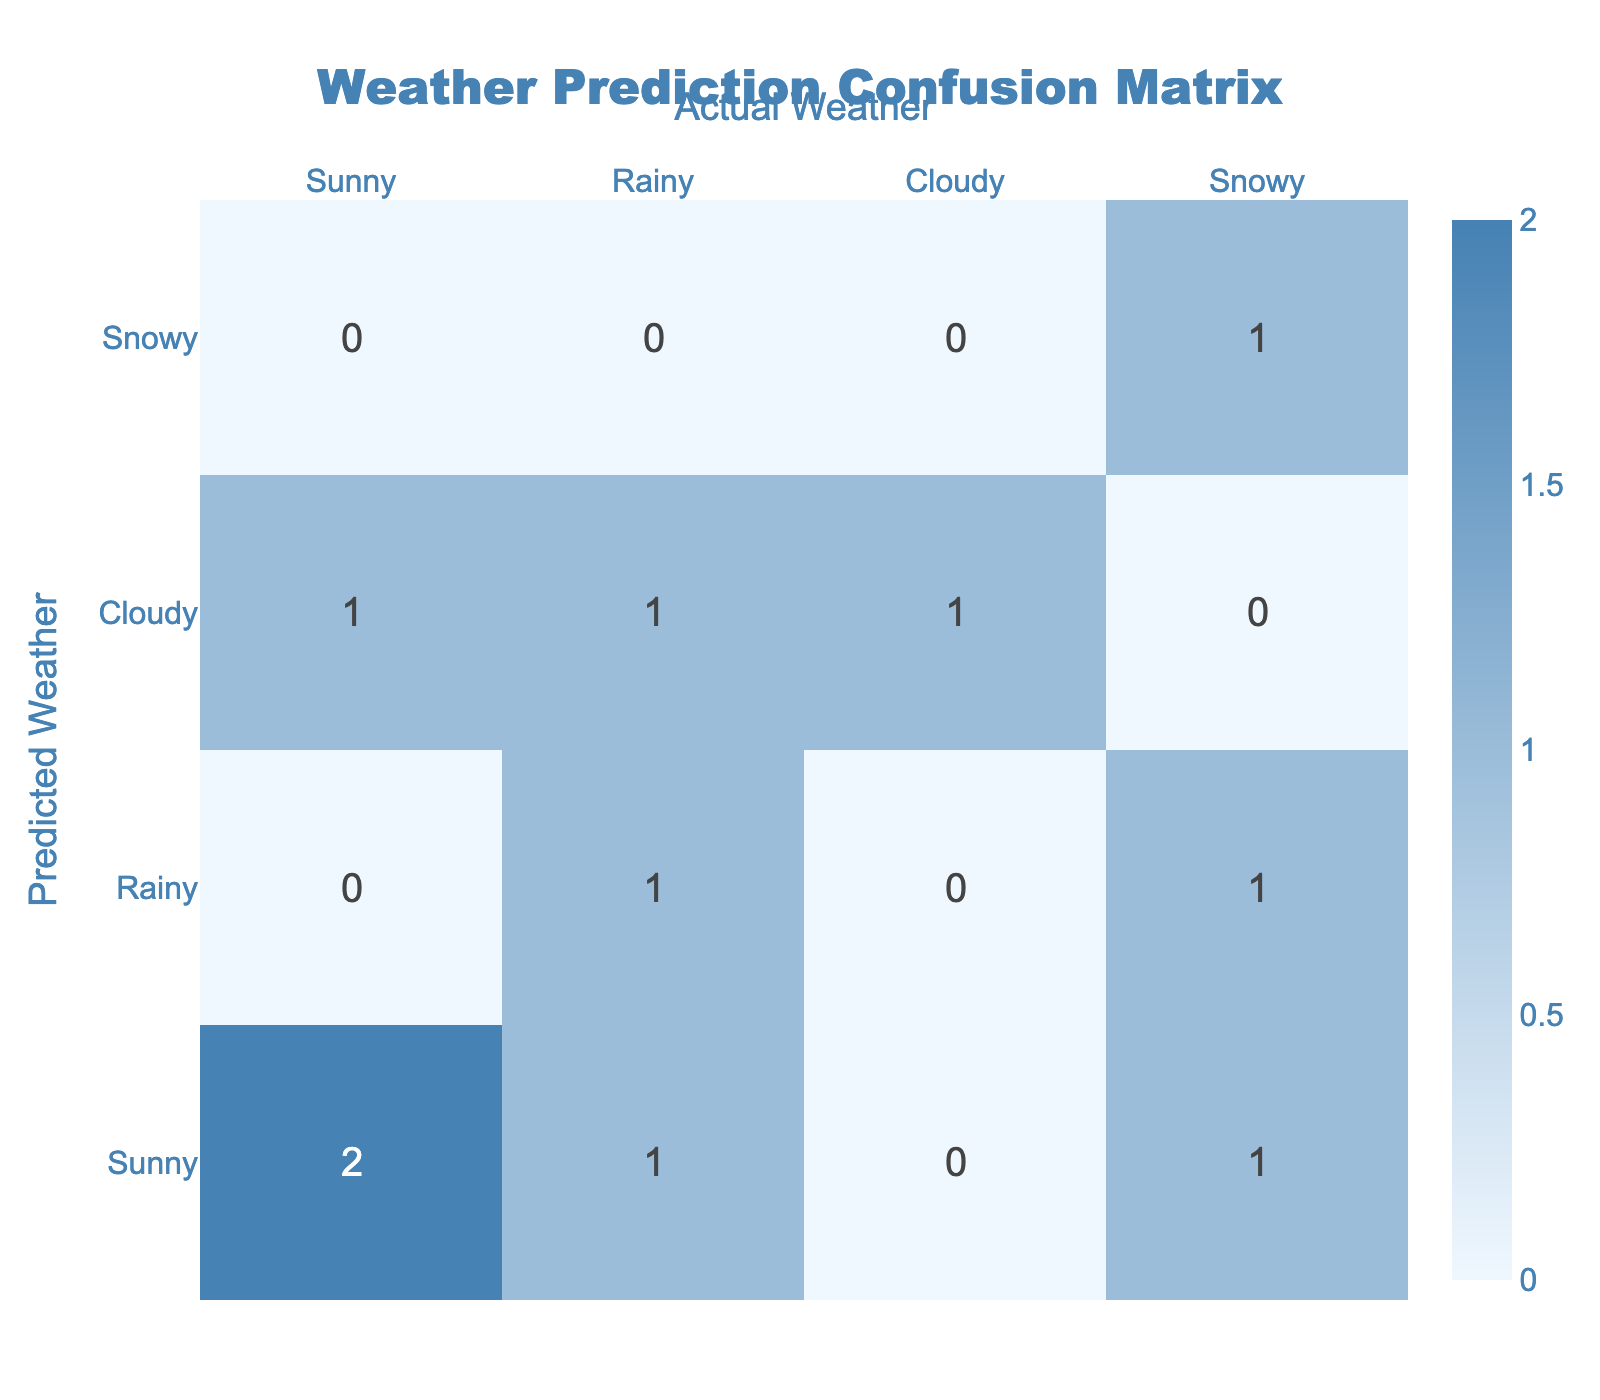What is the total number of times "Rainy" was predicted? In the table, we can see the predicted weather conditions. The rows for "Rainy" predictions include: EXP005 (Rainy, Rainy), EXP002 (Sunny, Rainy), and EXP009 (Cloudy, Rainy). Thus, the count is 3.
Answer: 3 What is the accuracy of the weather predictions? The accuracy can be calculated by dividing the number of correct predictions by the total number of predictions. The correct predictions are: EXP001, EXP004, EXP005, EXP006, EXP008 (5 correct), and there are 10 total predictions. Therefore, the accuracy is 5/10 = 0.5 or 50%.
Answer: 50% Did the predictions ever match the actual weather when it was "Cloudy"? To check if predictions matched when the actual weather was "Cloudy", we look at the row for actual "Cloudy": EXP004 (Cloudy, Cloudy). As it matched, the answer is yes.
Answer: Yes What is the difference between the number of "Sunny" predictions and "Snowy" actual outcomes? The number of "Sunny" predictions is 4 (EXP001, EXP002, EXP006, EXP007) and the number of "Snowy" actual outcomes is 2 (EXP003, EXP008). So the difference is 4 - 2 = 2.
Answer: 2 How many different types of weather were predicted correctly? Observing the table, the correct predictions are: Sunny (5 times), Rainy (2 times), Cloudy (1 time), and Snowy (2 times). Thus, the different types predicted correctly are 3 (Sunny, Rainy, Snowy).
Answer: 3 Which actual weather condition had the highest number of incorrect predictions? From the table, "Snowy" has 3 predictions that were incorrect (EXP003, EXP010), while the others have 1 or 2. Therefore, "Snowy" had the highest number of incorrect predictions.
Answer: Snowy What pattern can we observe from the predictions related to "Sunny"? By summarizing the "Sunny" row, we see the actual outcomes were Sunny (2), Rainy (1), Cloudy (1), and Snowy (1), indicating some uncertainty in predicting weather when anticipated sunny conditions could lead to a variance.
Answer: Mixed predictions What is the total number of correct predictions made for "Snowy"? Looking at the table, "Snowy" was predicted once, and it correctly matches the actual outcome once (EXP008). The total correct predictions made for "Snowy" is thus 1.
Answer: 1 